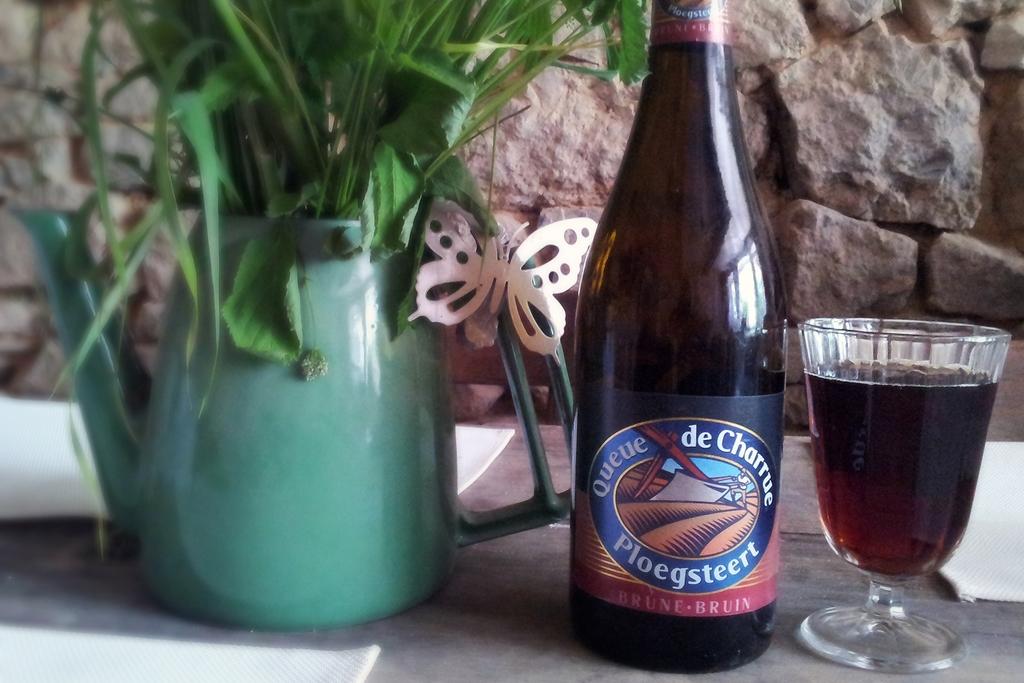What brand of drink is this?
Offer a terse response. Queue de charrue. 